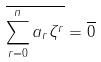<formula> <loc_0><loc_0><loc_500><loc_500>\overline { \sum _ { r = 0 } ^ { n } a _ { r } \zeta ^ { r } } = \overline { 0 }</formula> 